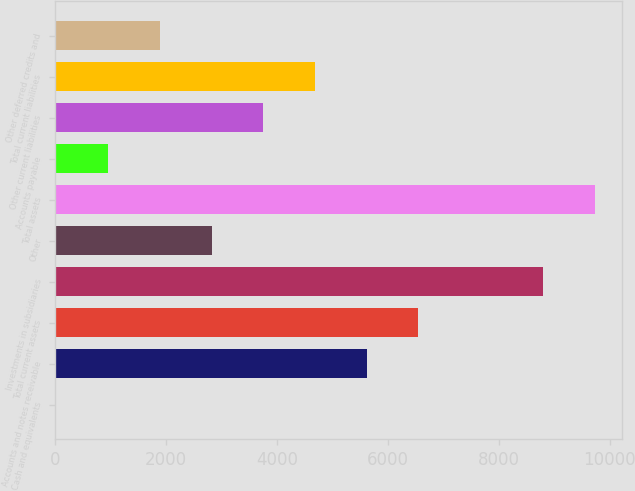<chart> <loc_0><loc_0><loc_500><loc_500><bar_chart><fcel>Cash and equivalents<fcel>Accounts and notes receivable<fcel>Total current assets<fcel>Investments in subsidiaries<fcel>Other<fcel>Total assets<fcel>Accounts payable<fcel>Other current liabilities<fcel>Total current liabilities<fcel>Other deferred credits and<nl><fcel>24<fcel>5617.2<fcel>6549.4<fcel>8801.2<fcel>2820.6<fcel>9733.4<fcel>956.2<fcel>3752.8<fcel>4685<fcel>1888.4<nl></chart> 